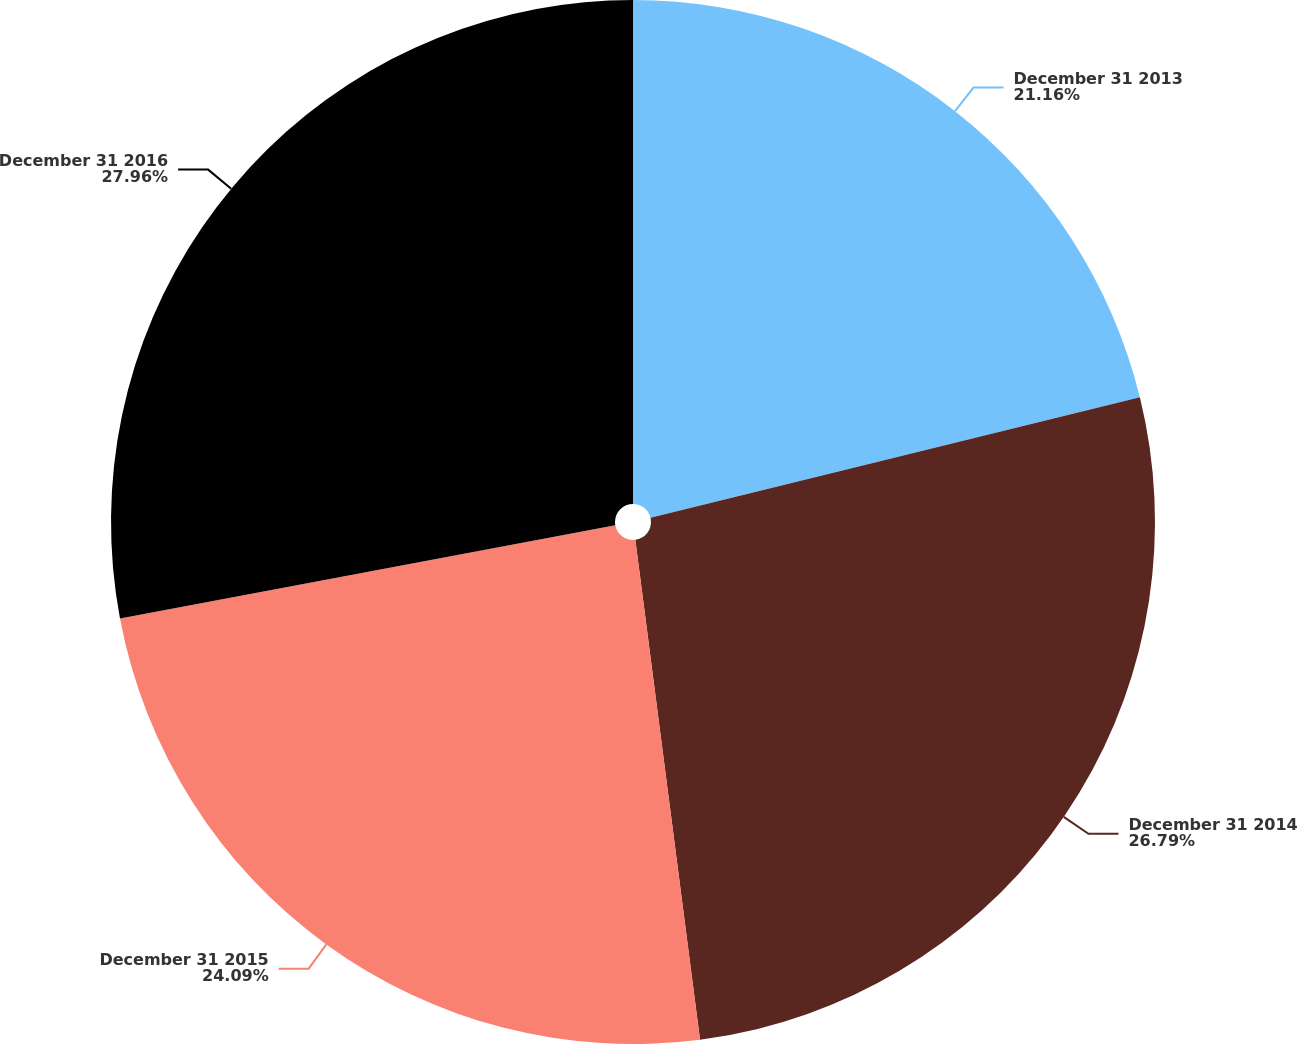Convert chart to OTSL. <chart><loc_0><loc_0><loc_500><loc_500><pie_chart><fcel>December 31 2013<fcel>December 31 2014<fcel>December 31 2015<fcel>December 31 2016<nl><fcel>21.16%<fcel>26.79%<fcel>24.09%<fcel>27.96%<nl></chart> 